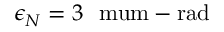Convert formula to latex. <formula><loc_0><loc_0><loc_500><loc_500>\epsilon _ { N } = 3 \ \ m u m - r a d</formula> 